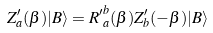Convert formula to latex. <formula><loc_0><loc_0><loc_500><loc_500>Z _ { a } ^ { \prime } ( \beta ) | B \rangle = { R ^ { \prime } } _ { a } ^ { b } ( \beta ) Z _ { b } ^ { \prime } ( - \beta ) | B \rangle</formula> 